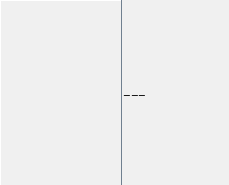Convert code to text. <code><loc_0><loc_0><loc_500><loc_500><_HTML_>
---
</code> 